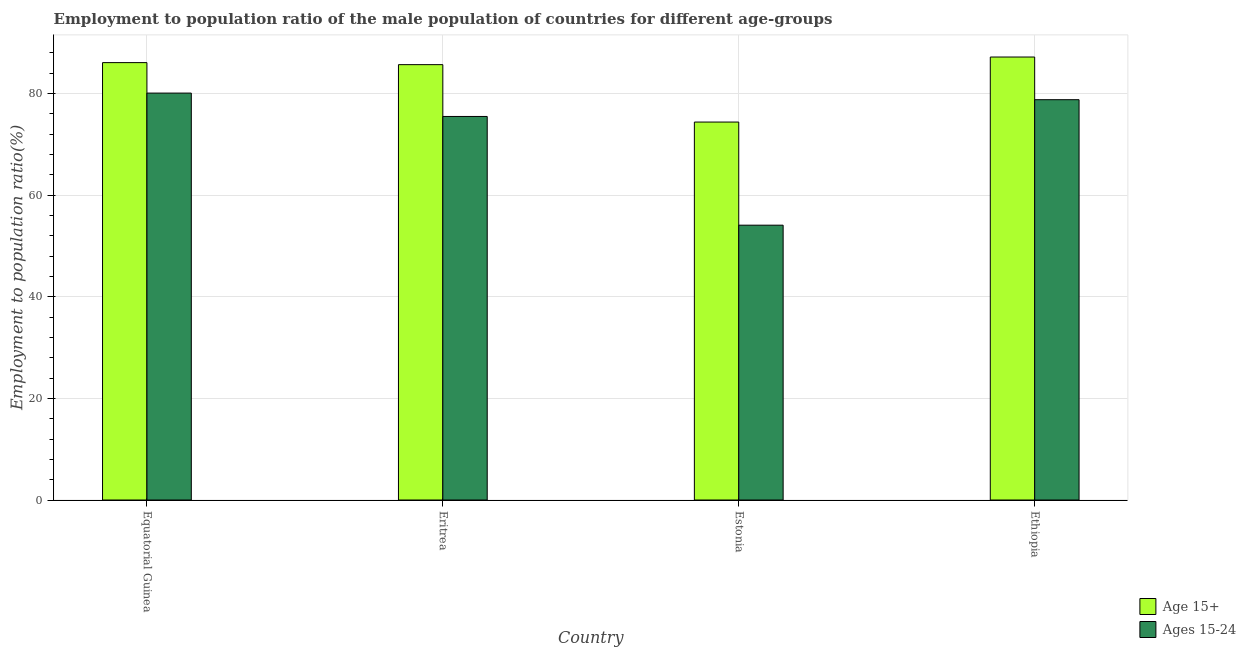How many different coloured bars are there?
Offer a very short reply. 2. How many groups of bars are there?
Give a very brief answer. 4. Are the number of bars per tick equal to the number of legend labels?
Your answer should be very brief. Yes. Are the number of bars on each tick of the X-axis equal?
Ensure brevity in your answer.  Yes. How many bars are there on the 3rd tick from the left?
Give a very brief answer. 2. How many bars are there on the 2nd tick from the right?
Offer a very short reply. 2. What is the label of the 2nd group of bars from the left?
Your answer should be very brief. Eritrea. What is the employment to population ratio(age 15-24) in Estonia?
Give a very brief answer. 54.1. Across all countries, what is the maximum employment to population ratio(age 15+)?
Ensure brevity in your answer.  87.2. Across all countries, what is the minimum employment to population ratio(age 15+)?
Offer a very short reply. 74.4. In which country was the employment to population ratio(age 15+) maximum?
Offer a very short reply. Ethiopia. In which country was the employment to population ratio(age 15+) minimum?
Your answer should be very brief. Estonia. What is the total employment to population ratio(age 15+) in the graph?
Offer a very short reply. 333.4. What is the difference between the employment to population ratio(age 15-24) in Equatorial Guinea and that in Eritrea?
Your response must be concise. 4.6. What is the difference between the employment to population ratio(age 15-24) in Equatorial Guinea and the employment to population ratio(age 15+) in Ethiopia?
Ensure brevity in your answer.  -7.1. What is the average employment to population ratio(age 15-24) per country?
Provide a succinct answer. 72.12. What is the difference between the employment to population ratio(age 15+) and employment to population ratio(age 15-24) in Ethiopia?
Ensure brevity in your answer.  8.4. What is the ratio of the employment to population ratio(age 15+) in Equatorial Guinea to that in Ethiopia?
Keep it short and to the point. 0.99. What is the difference between the highest and the second highest employment to population ratio(age 15+)?
Make the answer very short. 1.1. What is the difference between the highest and the lowest employment to population ratio(age 15-24)?
Make the answer very short. 26. In how many countries, is the employment to population ratio(age 15-24) greater than the average employment to population ratio(age 15-24) taken over all countries?
Provide a short and direct response. 3. What does the 1st bar from the left in Ethiopia represents?
Offer a terse response. Age 15+. What does the 2nd bar from the right in Estonia represents?
Offer a very short reply. Age 15+. How many bars are there?
Offer a terse response. 8. What is the difference between two consecutive major ticks on the Y-axis?
Provide a short and direct response. 20. Are the values on the major ticks of Y-axis written in scientific E-notation?
Your response must be concise. No. Does the graph contain any zero values?
Ensure brevity in your answer.  No. How many legend labels are there?
Give a very brief answer. 2. How are the legend labels stacked?
Your answer should be compact. Vertical. What is the title of the graph?
Provide a succinct answer. Employment to population ratio of the male population of countries for different age-groups. Does "Personal remittances" appear as one of the legend labels in the graph?
Offer a very short reply. No. What is the label or title of the X-axis?
Offer a terse response. Country. What is the label or title of the Y-axis?
Ensure brevity in your answer.  Employment to population ratio(%). What is the Employment to population ratio(%) in Age 15+ in Equatorial Guinea?
Make the answer very short. 86.1. What is the Employment to population ratio(%) in Ages 15-24 in Equatorial Guinea?
Make the answer very short. 80.1. What is the Employment to population ratio(%) of Age 15+ in Eritrea?
Provide a short and direct response. 85.7. What is the Employment to population ratio(%) in Ages 15-24 in Eritrea?
Ensure brevity in your answer.  75.5. What is the Employment to population ratio(%) in Age 15+ in Estonia?
Ensure brevity in your answer.  74.4. What is the Employment to population ratio(%) in Ages 15-24 in Estonia?
Offer a very short reply. 54.1. What is the Employment to population ratio(%) of Age 15+ in Ethiopia?
Provide a succinct answer. 87.2. What is the Employment to population ratio(%) of Ages 15-24 in Ethiopia?
Ensure brevity in your answer.  78.8. Across all countries, what is the maximum Employment to population ratio(%) of Age 15+?
Offer a terse response. 87.2. Across all countries, what is the maximum Employment to population ratio(%) of Ages 15-24?
Offer a very short reply. 80.1. Across all countries, what is the minimum Employment to population ratio(%) of Age 15+?
Offer a terse response. 74.4. Across all countries, what is the minimum Employment to population ratio(%) in Ages 15-24?
Your answer should be very brief. 54.1. What is the total Employment to population ratio(%) of Age 15+ in the graph?
Your response must be concise. 333.4. What is the total Employment to population ratio(%) of Ages 15-24 in the graph?
Give a very brief answer. 288.5. What is the difference between the Employment to population ratio(%) of Ages 15-24 in Equatorial Guinea and that in Eritrea?
Your answer should be compact. 4.6. What is the difference between the Employment to population ratio(%) in Age 15+ in Equatorial Guinea and that in Ethiopia?
Your answer should be compact. -1.1. What is the difference between the Employment to population ratio(%) in Ages 15-24 in Equatorial Guinea and that in Ethiopia?
Offer a very short reply. 1.3. What is the difference between the Employment to population ratio(%) of Age 15+ in Eritrea and that in Estonia?
Provide a succinct answer. 11.3. What is the difference between the Employment to population ratio(%) of Ages 15-24 in Eritrea and that in Estonia?
Offer a terse response. 21.4. What is the difference between the Employment to population ratio(%) of Age 15+ in Eritrea and that in Ethiopia?
Offer a very short reply. -1.5. What is the difference between the Employment to population ratio(%) of Ages 15-24 in Eritrea and that in Ethiopia?
Ensure brevity in your answer.  -3.3. What is the difference between the Employment to population ratio(%) in Age 15+ in Estonia and that in Ethiopia?
Make the answer very short. -12.8. What is the difference between the Employment to population ratio(%) in Ages 15-24 in Estonia and that in Ethiopia?
Keep it short and to the point. -24.7. What is the difference between the Employment to population ratio(%) of Age 15+ in Equatorial Guinea and the Employment to population ratio(%) of Ages 15-24 in Eritrea?
Make the answer very short. 10.6. What is the difference between the Employment to population ratio(%) of Age 15+ in Eritrea and the Employment to population ratio(%) of Ages 15-24 in Estonia?
Ensure brevity in your answer.  31.6. What is the difference between the Employment to population ratio(%) in Age 15+ in Eritrea and the Employment to population ratio(%) in Ages 15-24 in Ethiopia?
Offer a terse response. 6.9. What is the difference between the Employment to population ratio(%) of Age 15+ in Estonia and the Employment to population ratio(%) of Ages 15-24 in Ethiopia?
Keep it short and to the point. -4.4. What is the average Employment to population ratio(%) in Age 15+ per country?
Provide a succinct answer. 83.35. What is the average Employment to population ratio(%) in Ages 15-24 per country?
Your answer should be very brief. 72.12. What is the difference between the Employment to population ratio(%) in Age 15+ and Employment to population ratio(%) in Ages 15-24 in Equatorial Guinea?
Offer a terse response. 6. What is the difference between the Employment to population ratio(%) in Age 15+ and Employment to population ratio(%) in Ages 15-24 in Estonia?
Ensure brevity in your answer.  20.3. What is the difference between the Employment to population ratio(%) in Age 15+ and Employment to population ratio(%) in Ages 15-24 in Ethiopia?
Your response must be concise. 8.4. What is the ratio of the Employment to population ratio(%) of Ages 15-24 in Equatorial Guinea to that in Eritrea?
Offer a terse response. 1.06. What is the ratio of the Employment to population ratio(%) in Age 15+ in Equatorial Guinea to that in Estonia?
Your answer should be very brief. 1.16. What is the ratio of the Employment to population ratio(%) in Ages 15-24 in Equatorial Guinea to that in Estonia?
Provide a succinct answer. 1.48. What is the ratio of the Employment to population ratio(%) of Age 15+ in Equatorial Guinea to that in Ethiopia?
Ensure brevity in your answer.  0.99. What is the ratio of the Employment to population ratio(%) in Ages 15-24 in Equatorial Guinea to that in Ethiopia?
Your response must be concise. 1.02. What is the ratio of the Employment to population ratio(%) of Age 15+ in Eritrea to that in Estonia?
Your answer should be very brief. 1.15. What is the ratio of the Employment to population ratio(%) in Ages 15-24 in Eritrea to that in Estonia?
Offer a very short reply. 1.4. What is the ratio of the Employment to population ratio(%) of Age 15+ in Eritrea to that in Ethiopia?
Provide a short and direct response. 0.98. What is the ratio of the Employment to population ratio(%) of Ages 15-24 in Eritrea to that in Ethiopia?
Offer a terse response. 0.96. What is the ratio of the Employment to population ratio(%) of Age 15+ in Estonia to that in Ethiopia?
Give a very brief answer. 0.85. What is the ratio of the Employment to population ratio(%) in Ages 15-24 in Estonia to that in Ethiopia?
Provide a succinct answer. 0.69. What is the difference between the highest and the second highest Employment to population ratio(%) of Age 15+?
Your answer should be very brief. 1.1. What is the difference between the highest and the second highest Employment to population ratio(%) in Ages 15-24?
Provide a succinct answer. 1.3. What is the difference between the highest and the lowest Employment to population ratio(%) in Ages 15-24?
Your answer should be very brief. 26. 